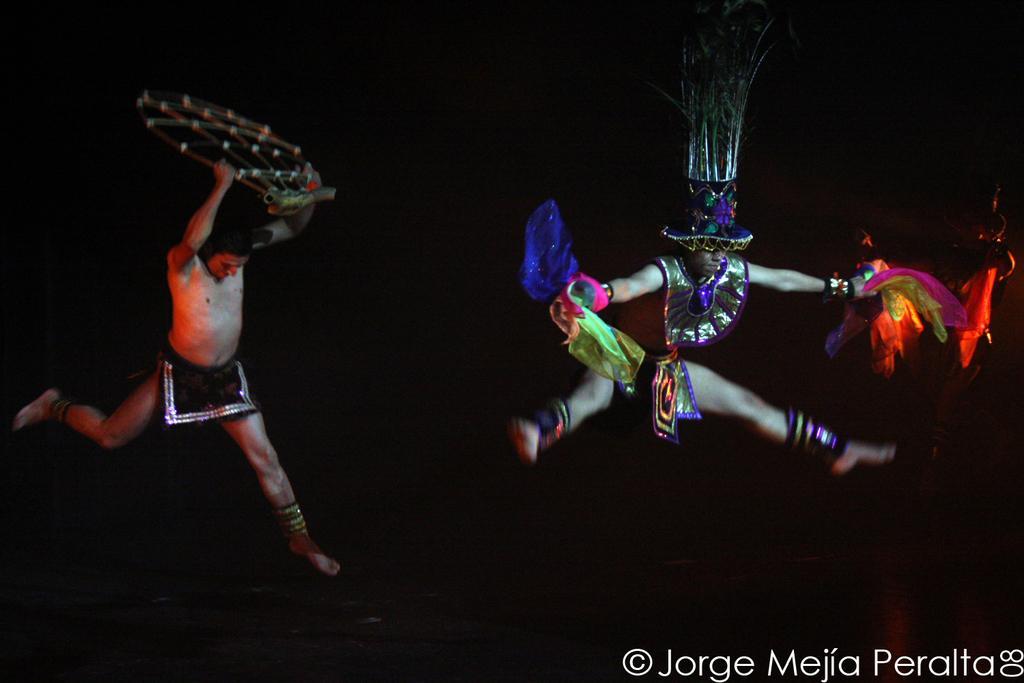In one or two sentences, can you explain what this image depicts? In this image we can see men performing an art form. 